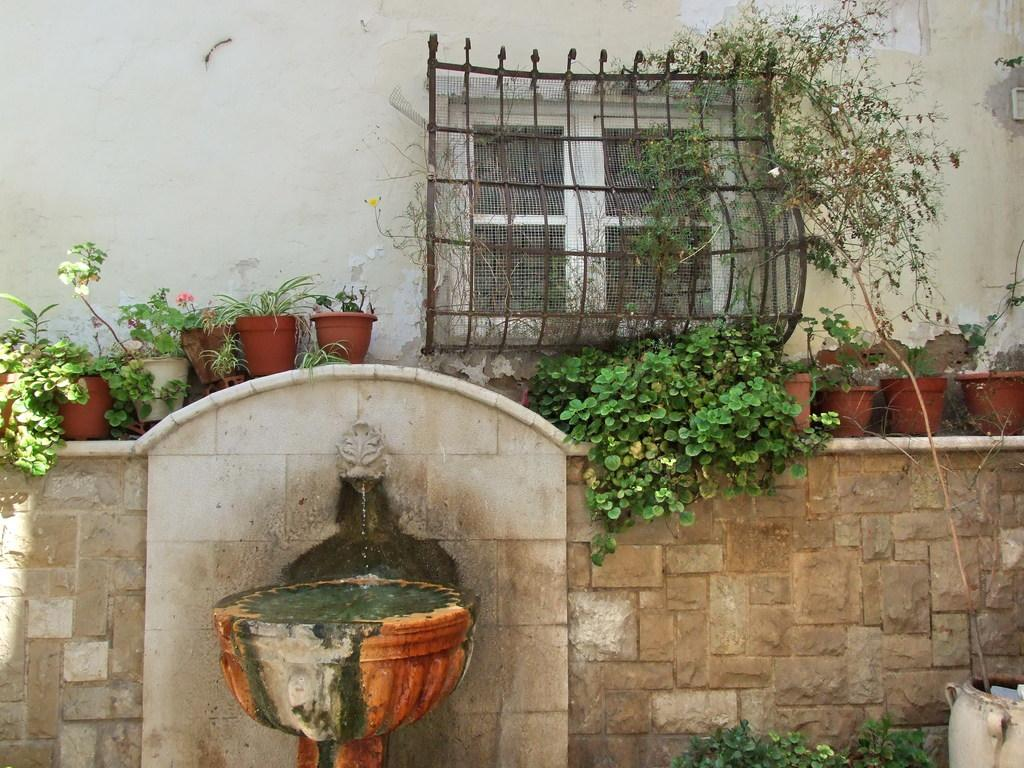What is the main object in the image? There is a pot in the image. What can be seen through the window in the image? There is a window in the image, but the view through it is not specified. What is the mesh used for in the image? The mesh is present in the image, but its purpose is not mentioned. What type of plants are in the image? There are house plants in the image. What is the structure surrounding the pot and plants? There are walls in the image. What is the water contained in within the image? There is water in an object in the image, but the object is not specified. Can you describe the unspecified objects in the image? There are some unspecified objects in the image, but their details are not provided. Can you see a kite flying outside the window in the image? There is no mention of a kite or any outdoor activity in the image. Is there a rat hiding behind the pot in the image? There is no mention of a rat or any animals in the image. Are there any potatoes growing in the pot in the image? There is no mention of potatoes or any edible plants in the image. 